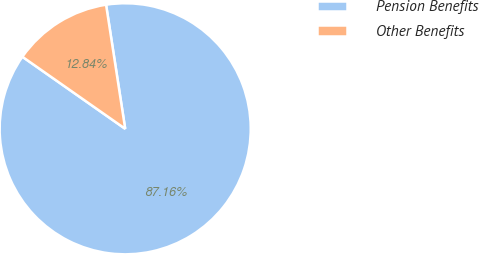Convert chart to OTSL. <chart><loc_0><loc_0><loc_500><loc_500><pie_chart><fcel>Pension Benefits<fcel>Other Benefits<nl><fcel>87.16%<fcel>12.84%<nl></chart> 